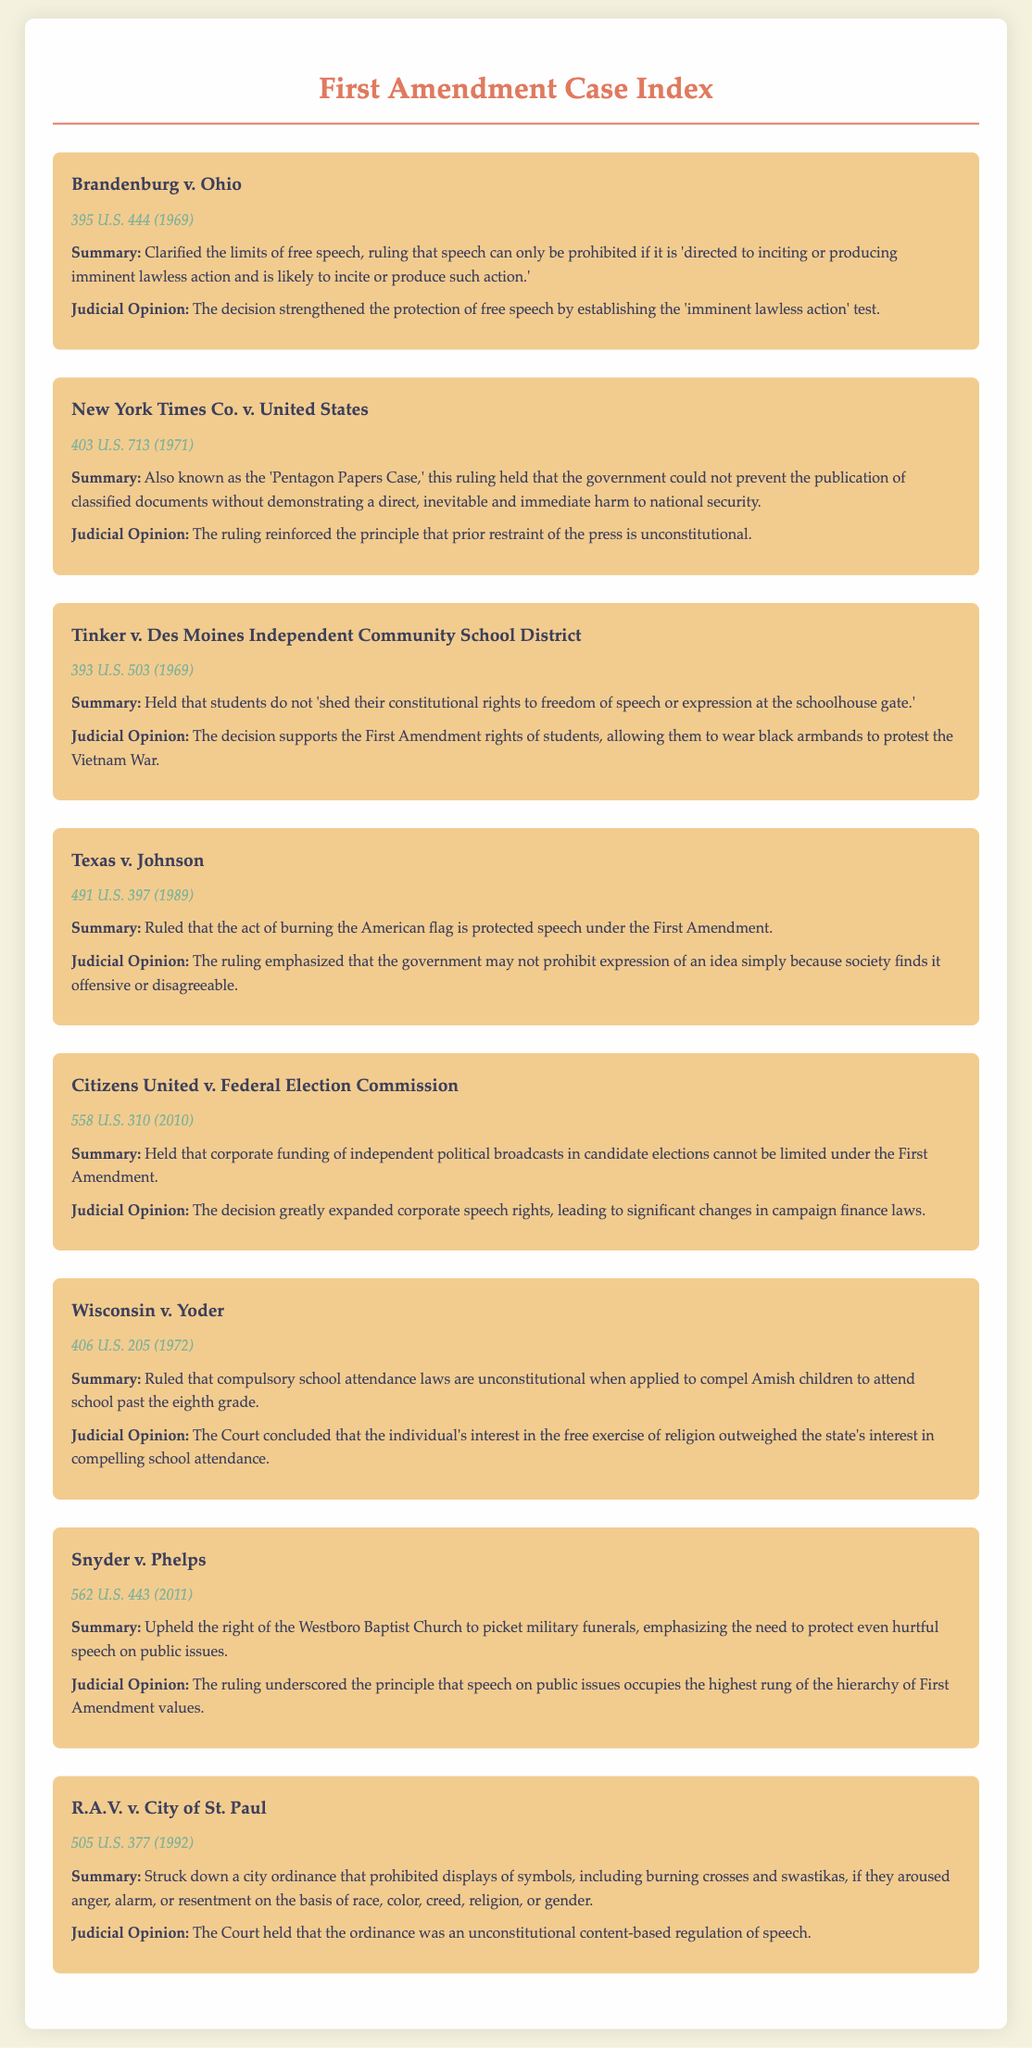What is the citation for Brandenburg v. Ohio? The citation is found under the case name and provides the full court citation for the case.
Answer: 395 U.S. 444 (1969) What was the ruling in Texas v. Johnson? The ruling is summarized in the document and reflects the outcome of the case regarding flag burning.
Answer: The act of burning the American flag is protected speech under the First Amendment What year was Citizens United v. Federal Election Commission decided? The year is located in the citation of the case and provides information about the case's decision date.
Answer: 2010 Which case emphasized the importance of protecting hurtful speech on public issues? The reasoning involves a review of the cases and their judicial opinions to identify the appropriate ruling.
Answer: Snyder v. Phelps What is the main conclusion of Wisconsin v. Yoder? The conclusion is highlighted in the opinion section and summarizes the outcome related to religious freedoms.
Answer: The individual's interest in the free exercise of religion outweighed the state's interest in compelling school attendance How does the opinion in New York Times Co. v. United States describe prior restraint? The opinion section outlines the judicial articulation regarding government intervention with the press.
Answer: Prior restraint of the press is unconstitutional What symbol was involved in the ordinance struck down in R.A.V. v. City of St. Paul? The specific symbols mentioned in the case allow for a clear identification of the content at issue.
Answer: Burning crosses and swastikas What does the summary of Tinker v. Des Moines Independent Community School District state about students' rights? The summary specifies the rights children have in the educational environment in relation to free speech.
Answer: Students do not 'shed their constitutional rights to freedom of speech or expression at the schoolhouse gate.' 